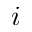Convert formula to latex. <formula><loc_0><loc_0><loc_500><loc_500>{ i }</formula> 